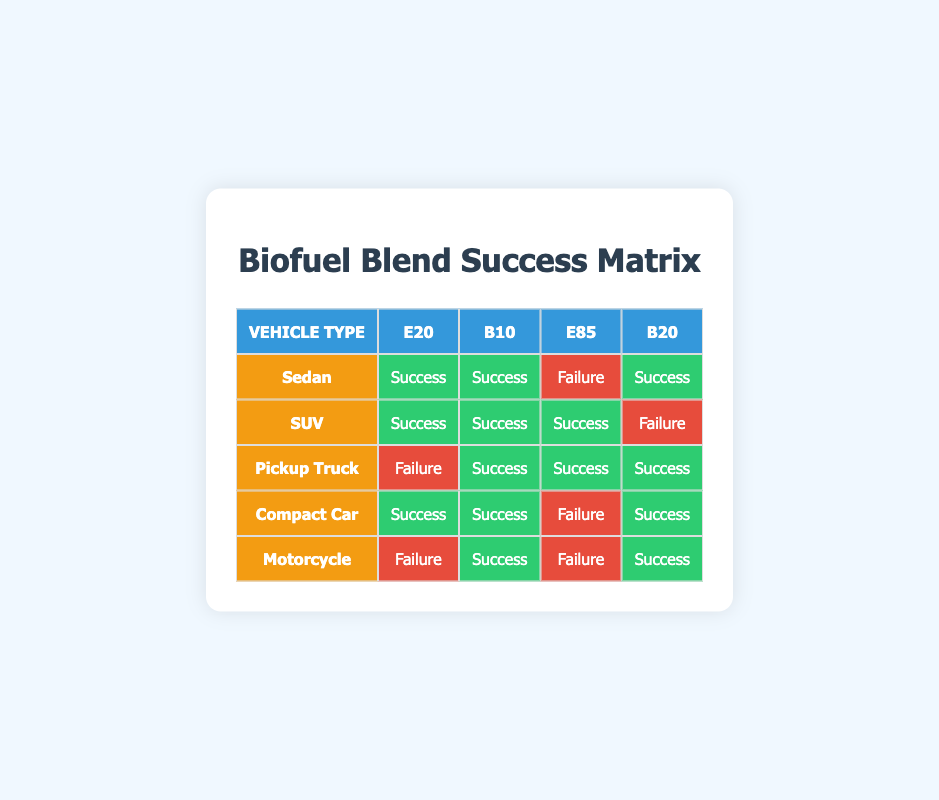What is the success rate of the E20 blend in Sedans? The table indicates that the E20 blend is labeled as "Success" for Sedans. Therefore, the success rate is 100% for this vehicle type with E20.
Answer: 100% Which vehicle type had the highest success with the B10 blend? From the table, all vehicle types show "Success" with the B10 blend. Since every vehicle type is represented positively, the answer is that all types had the same high success rate with B10.
Answer: All vehicle types How many vehicle types had a failure rate with the E85 blend? Referring to the table, the E85 blend shows one "Failure" for Sedans, one "Failure" for Compact Cars, and one "Failure" for Motorcycles. Thus, a total of three vehicle types had a failure rate with the E85 blend.
Answer: 3 Is the B20 blend successful for Pickup Trucks? The table shows "Success" for the B20 blend in Pickup Trucks. Therefore, the answer is yes, the B20 blend is successful for this vehicle type.
Answer: Yes Which blend was successful for the maximum number of vehicle types? By analyzing the table, the B10 blend had a success rate of "Success" across all vehicle types (Sedans, SUVs, Pickup Trucks, Compact Cars, and Motorcycles). Therefore, it is successful for five vehicle types.
Answer: B10 blend What is the failure success count across all blends for SUVs? The table indicates that SUVs showed failures only with the B20 blend. Thus, the failure count for SUVs is one.
Answer: 1 How do the success rates of E20 and B20 compare for Compact Cars? The table indicates "Success" for B20 and "Success" also for E20 in Compact Cars, which means that both blends are equally successful for this vehicle type.
Answer: Equal success Which vehicle type performs best overall across all blends? In assessing performance across blends, the Pickup Truck had "Success" with B10, E85, and B20, but "Failure" with E20. Comparatively, the SUV had "Success" for B10 and E85 but "Failure" with B20. Thus, considering the highest number of successes, the Pickup Truck performs best overall with three successful blends.
Answer: Pickup Truck 